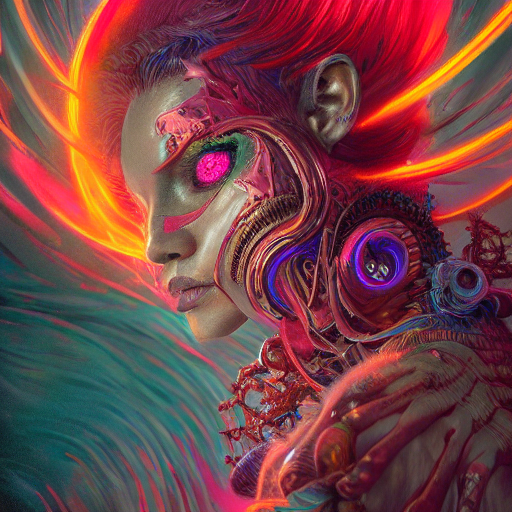What emotions does the facial expression of the figure convey? The figure's facial expression appears contemplative and serene, perhaps suggesting an inner calm or acceptance of the symbiotic relationship between the organic and the mechanical aspects of its being. 